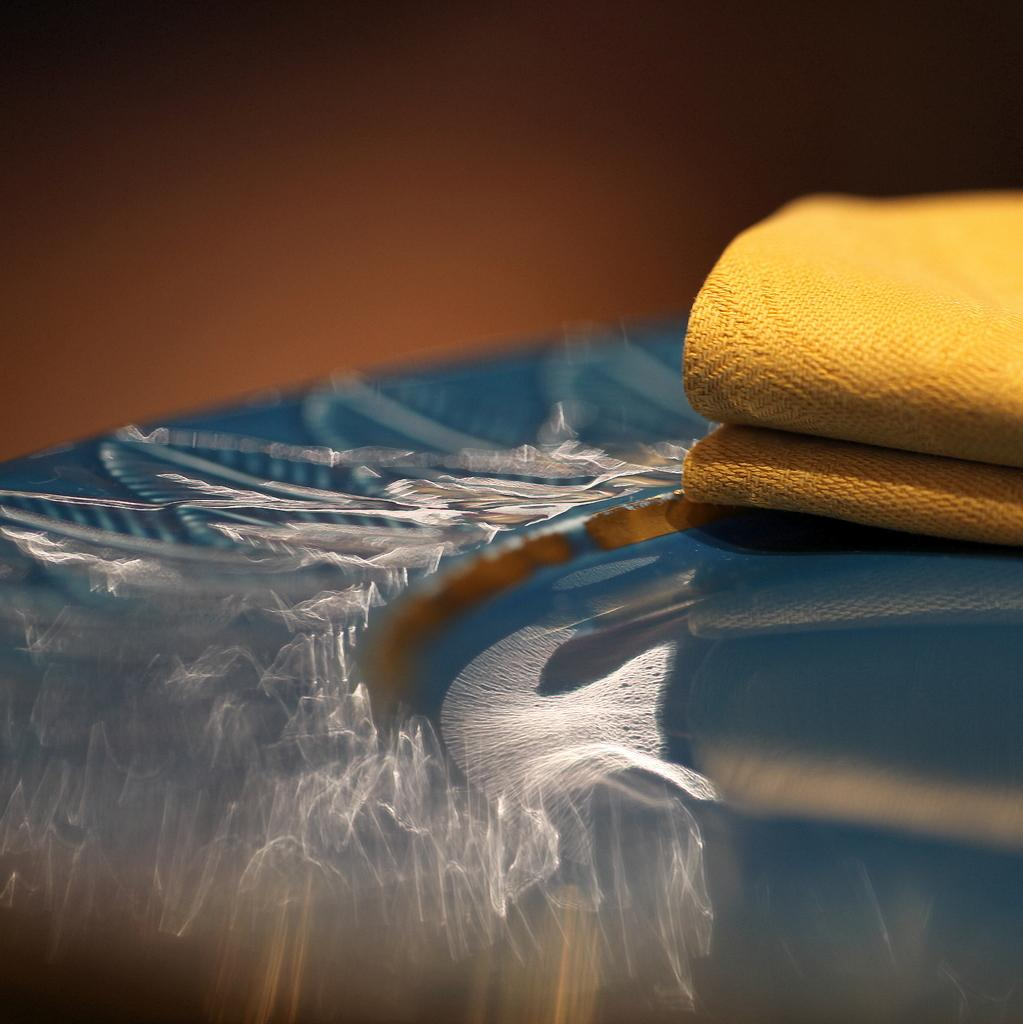What is placed on the plate in the image? There is a napkin on a plate in the image. What type of religion is practiced in the image? There is no indication of any religious practice in the image; it only features a napkin on a plate. What type of linen is used for the napkin in the image? The type of linen used for the napkin cannot be determined from the image alone. 